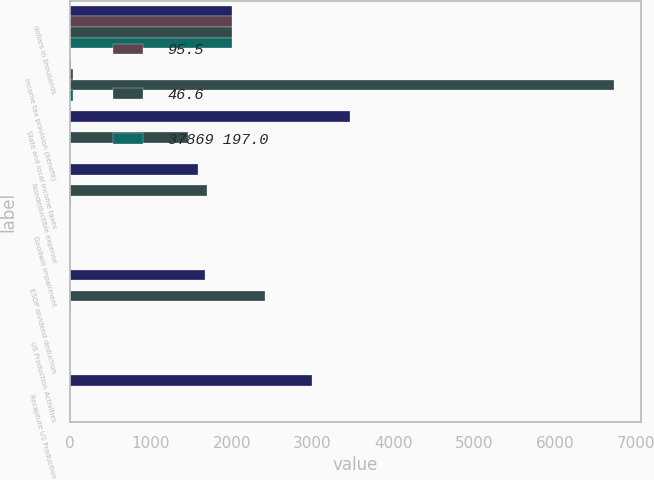<chart> <loc_0><loc_0><loc_500><loc_500><stacked_bar_chart><ecel><fcel>dollars in thousands<fcel>Income tax provision (benefit)<fcel>State and local income taxes<fcel>Nondeductible expense<fcel>Goodwill impairment<fcel>ESOP dividend deduction<fcel>US Production Activities<fcel>Recapture US Production<nl><fcel>nan<fcel>2010<fcel>8.8<fcel>3465<fcel>1583<fcel>0<fcel>1665<fcel>0<fcel>2993<nl><fcel>95.5<fcel>2010<fcel>35<fcel>1.8<fcel>0.8<fcel>0<fcel>0.9<fcel>0<fcel>1.6<nl><fcel>46.6<fcel>2009<fcel>6727<fcel>1457<fcel>1694<fcel>0<fcel>2408<fcel>0<fcel>0<nl><fcel>37869 197.0<fcel>2009<fcel>35<fcel>7.6<fcel>8.8<fcel>0<fcel>12.5<fcel>0<fcel>0<nl></chart> 